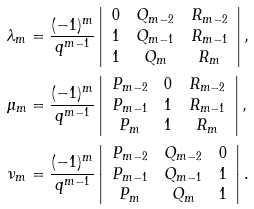<formula> <loc_0><loc_0><loc_500><loc_500>\lambda _ { m } & = \frac { ( - 1 ) ^ { m } } { q ^ { m - 1 } } \left | \begin{array} { c c c } 0 & Q _ { m - 2 } & R _ { m - 2 } \\ 1 & Q _ { m - 1 } & R _ { m - 1 } \\ 1 & Q _ { m } & R _ { m } \\ \end{array} \right | , \\ \mu _ { m } & = \frac { ( - 1 ) ^ { m } } { q ^ { m - 1 } } \left | \begin{array} { c c c } P _ { m - 2 } & 0 & R _ { m - 2 } \\ P _ { m - 1 } & 1 & R _ { m - 1 } \\ P _ { m } & 1 & R _ { m } \\ \end{array} \right | , \\ \nu _ { m } & = \frac { ( - 1 ) ^ { m } } { q ^ { m - 1 } } \left | \begin{array} { c c c } P _ { m - 2 } & Q _ { m - 2 } & 0 \\ P _ { m - 1 } & Q _ { m - 1 } & 1 \\ P _ { m } & Q _ { m } & 1 \\ \end{array} \right | .</formula> 